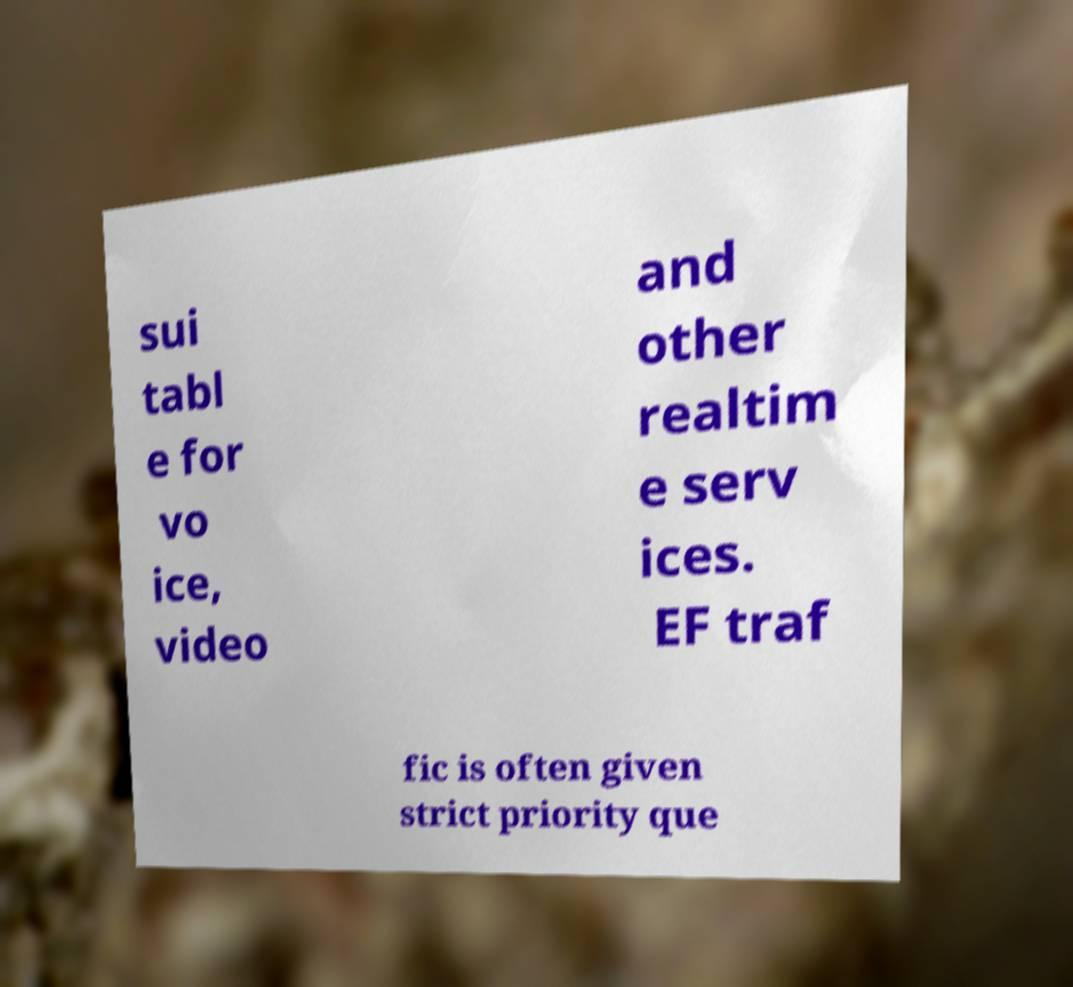Please identify and transcribe the text found in this image. sui tabl e for vo ice, video and other realtim e serv ices. EF traf fic is often given strict priority que 